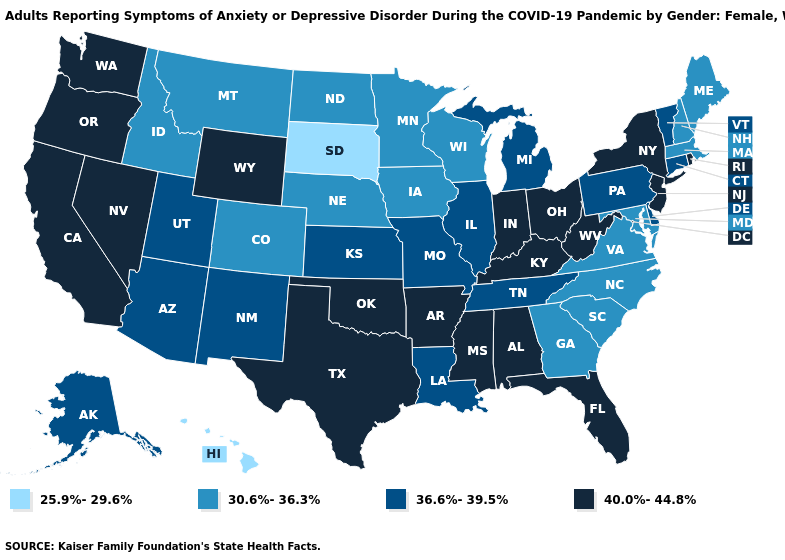Does Louisiana have a higher value than North Carolina?
Short answer required. Yes. Does the map have missing data?
Answer briefly. No. Among the states that border Nevada , which have the highest value?
Concise answer only. California, Oregon. Does New Jersey have the highest value in the Northeast?
Keep it brief. Yes. Name the states that have a value in the range 40.0%-44.8%?
Give a very brief answer. Alabama, Arkansas, California, Florida, Indiana, Kentucky, Mississippi, Nevada, New Jersey, New York, Ohio, Oklahoma, Oregon, Rhode Island, Texas, Washington, West Virginia, Wyoming. Does Texas have the highest value in the USA?
Concise answer only. Yes. Is the legend a continuous bar?
Answer briefly. No. Name the states that have a value in the range 30.6%-36.3%?
Answer briefly. Colorado, Georgia, Idaho, Iowa, Maine, Maryland, Massachusetts, Minnesota, Montana, Nebraska, New Hampshire, North Carolina, North Dakota, South Carolina, Virginia, Wisconsin. Name the states that have a value in the range 36.6%-39.5%?
Be succinct. Alaska, Arizona, Connecticut, Delaware, Illinois, Kansas, Louisiana, Michigan, Missouri, New Mexico, Pennsylvania, Tennessee, Utah, Vermont. Name the states that have a value in the range 40.0%-44.8%?
Short answer required. Alabama, Arkansas, California, Florida, Indiana, Kentucky, Mississippi, Nevada, New Jersey, New York, Ohio, Oklahoma, Oregon, Rhode Island, Texas, Washington, West Virginia, Wyoming. Does the first symbol in the legend represent the smallest category?
Be succinct. Yes. Does Maine have the same value as New Hampshire?
Answer briefly. Yes. What is the value of Michigan?
Short answer required. 36.6%-39.5%. Does West Virginia have the highest value in the USA?
Concise answer only. Yes. Among the states that border Nebraska , does Wyoming have the highest value?
Concise answer only. Yes. 